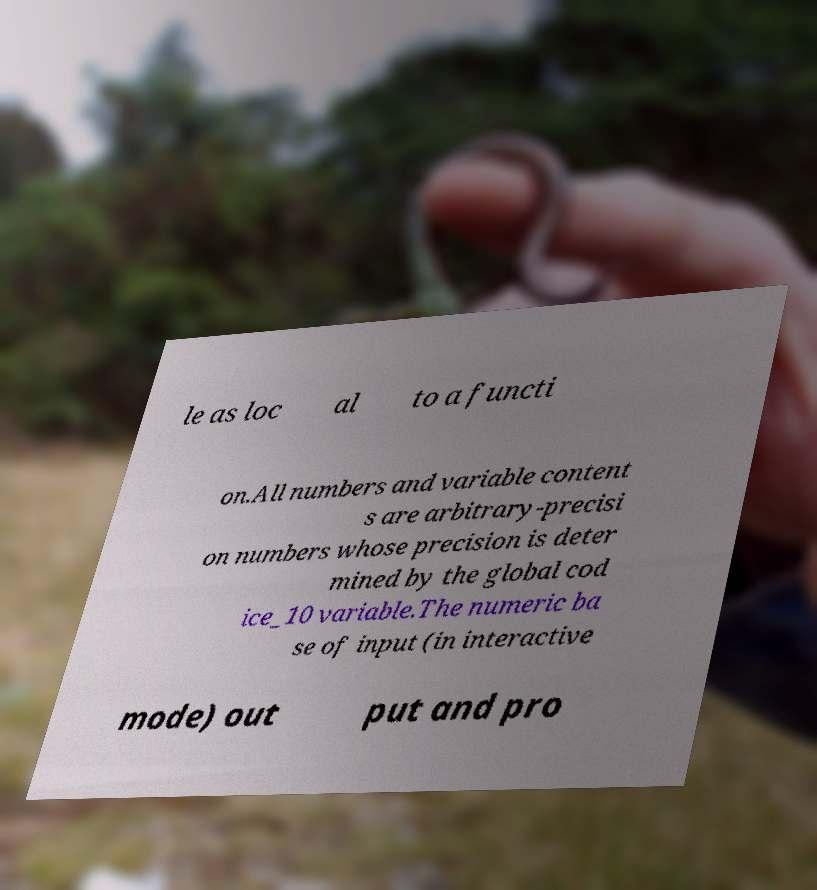Can you read and provide the text displayed in the image?This photo seems to have some interesting text. Can you extract and type it out for me? le as loc al to a functi on.All numbers and variable content s are arbitrary-precisi on numbers whose precision is deter mined by the global cod ice_10 variable.The numeric ba se of input (in interactive mode) out put and pro 